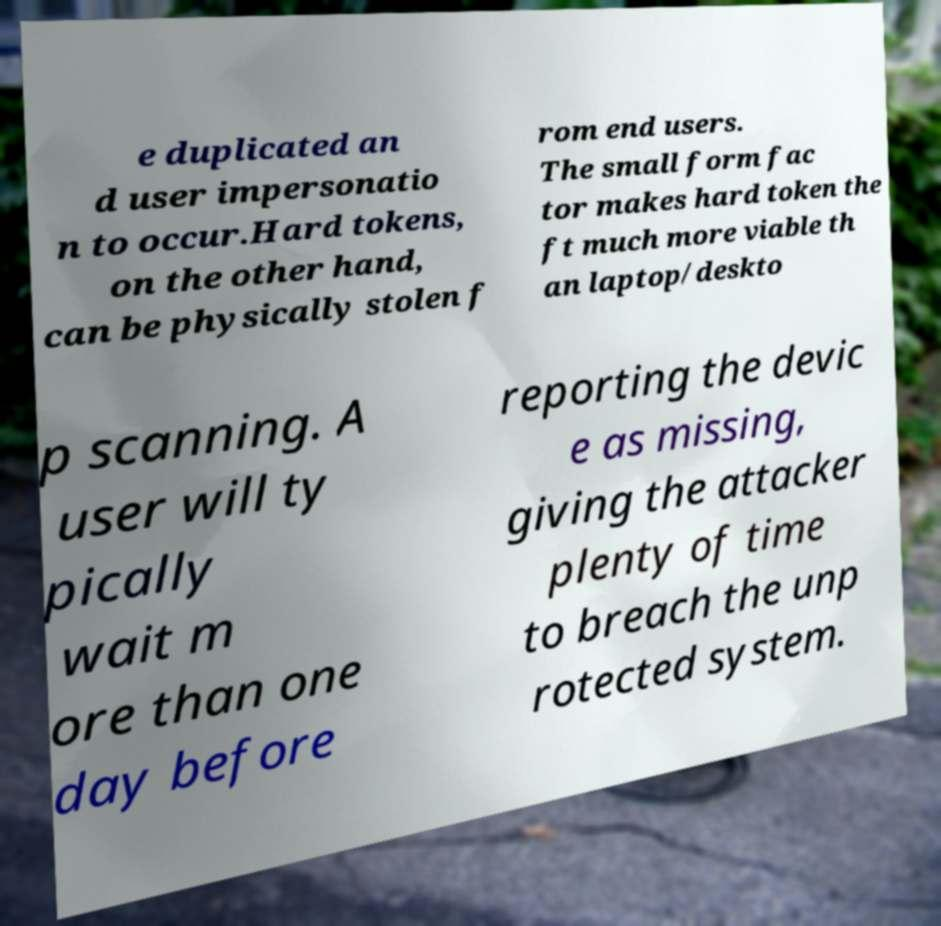For documentation purposes, I need the text within this image transcribed. Could you provide that? e duplicated an d user impersonatio n to occur.Hard tokens, on the other hand, can be physically stolen f rom end users. The small form fac tor makes hard token the ft much more viable th an laptop/deskto p scanning. A user will ty pically wait m ore than one day before reporting the devic e as missing, giving the attacker plenty of time to breach the unp rotected system. 